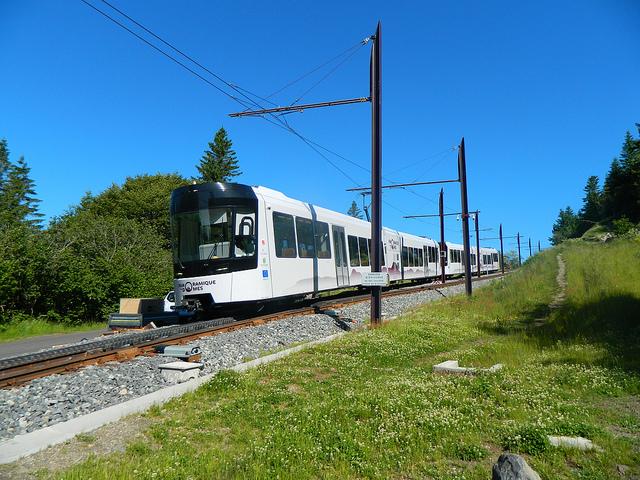How many poles are there?
Write a very short answer. 8. What is on the grass?
Answer briefly. Rocks. Is this a farm?
Keep it brief. No. What form of transportation is in the picture?
Give a very brief answer. Train. 